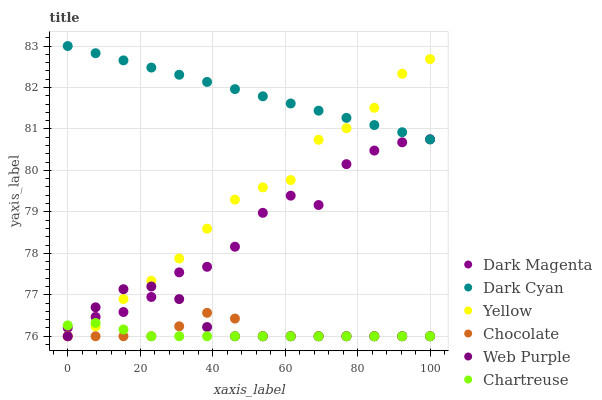Does Chartreuse have the minimum area under the curve?
Answer yes or no. Yes. Does Dark Cyan have the maximum area under the curve?
Answer yes or no. Yes. Does Web Purple have the minimum area under the curve?
Answer yes or no. No. Does Web Purple have the maximum area under the curve?
Answer yes or no. No. Is Dark Cyan the smoothest?
Answer yes or no. Yes. Is Dark Magenta the roughest?
Answer yes or no. Yes. Is Web Purple the smoothest?
Answer yes or no. No. Is Web Purple the roughest?
Answer yes or no. No. Does Web Purple have the lowest value?
Answer yes or no. Yes. Does Dark Cyan have the lowest value?
Answer yes or no. No. Does Dark Cyan have the highest value?
Answer yes or no. Yes. Does Web Purple have the highest value?
Answer yes or no. No. Is Web Purple less than Dark Cyan?
Answer yes or no. Yes. Is Dark Cyan greater than Chocolate?
Answer yes or no. Yes. Does Chocolate intersect Chartreuse?
Answer yes or no. Yes. Is Chocolate less than Chartreuse?
Answer yes or no. No. Is Chocolate greater than Chartreuse?
Answer yes or no. No. Does Web Purple intersect Dark Cyan?
Answer yes or no. No. 